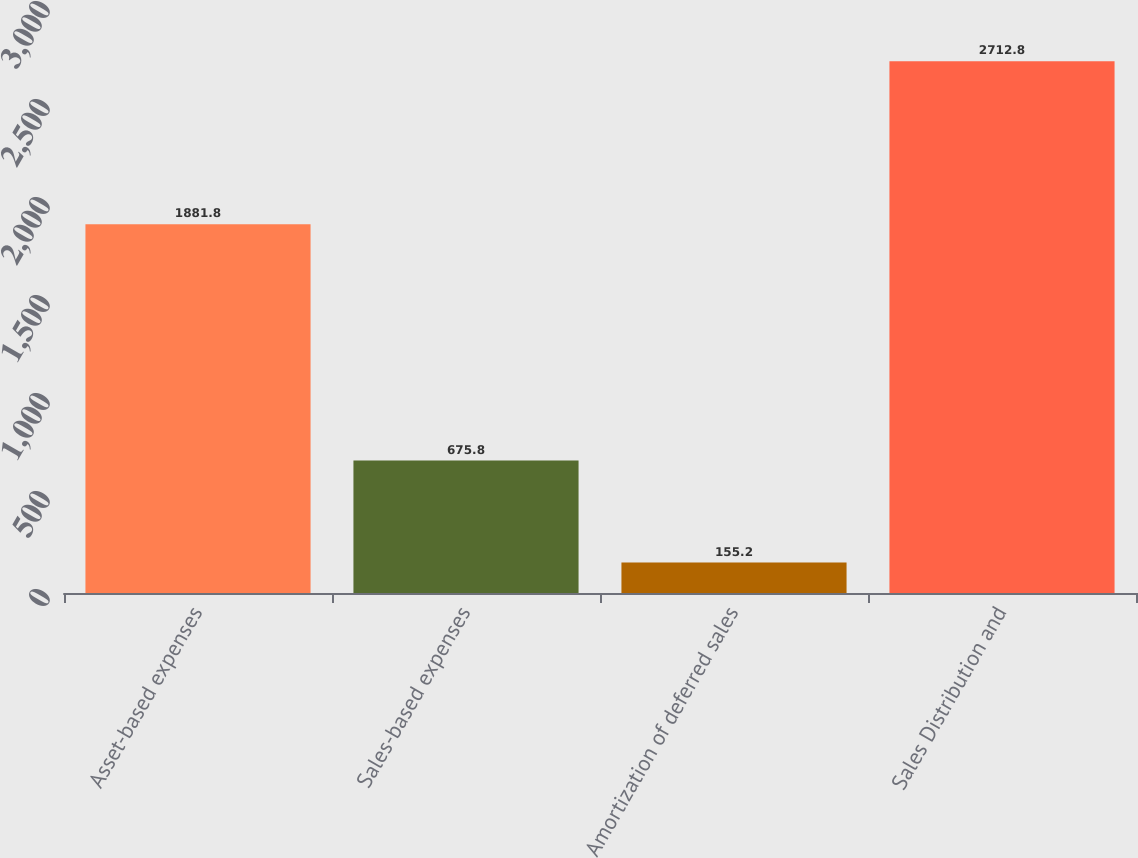Convert chart to OTSL. <chart><loc_0><loc_0><loc_500><loc_500><bar_chart><fcel>Asset-based expenses<fcel>Sales-based expenses<fcel>Amortization of deferred sales<fcel>Sales Distribution and<nl><fcel>1881.8<fcel>675.8<fcel>155.2<fcel>2712.8<nl></chart> 